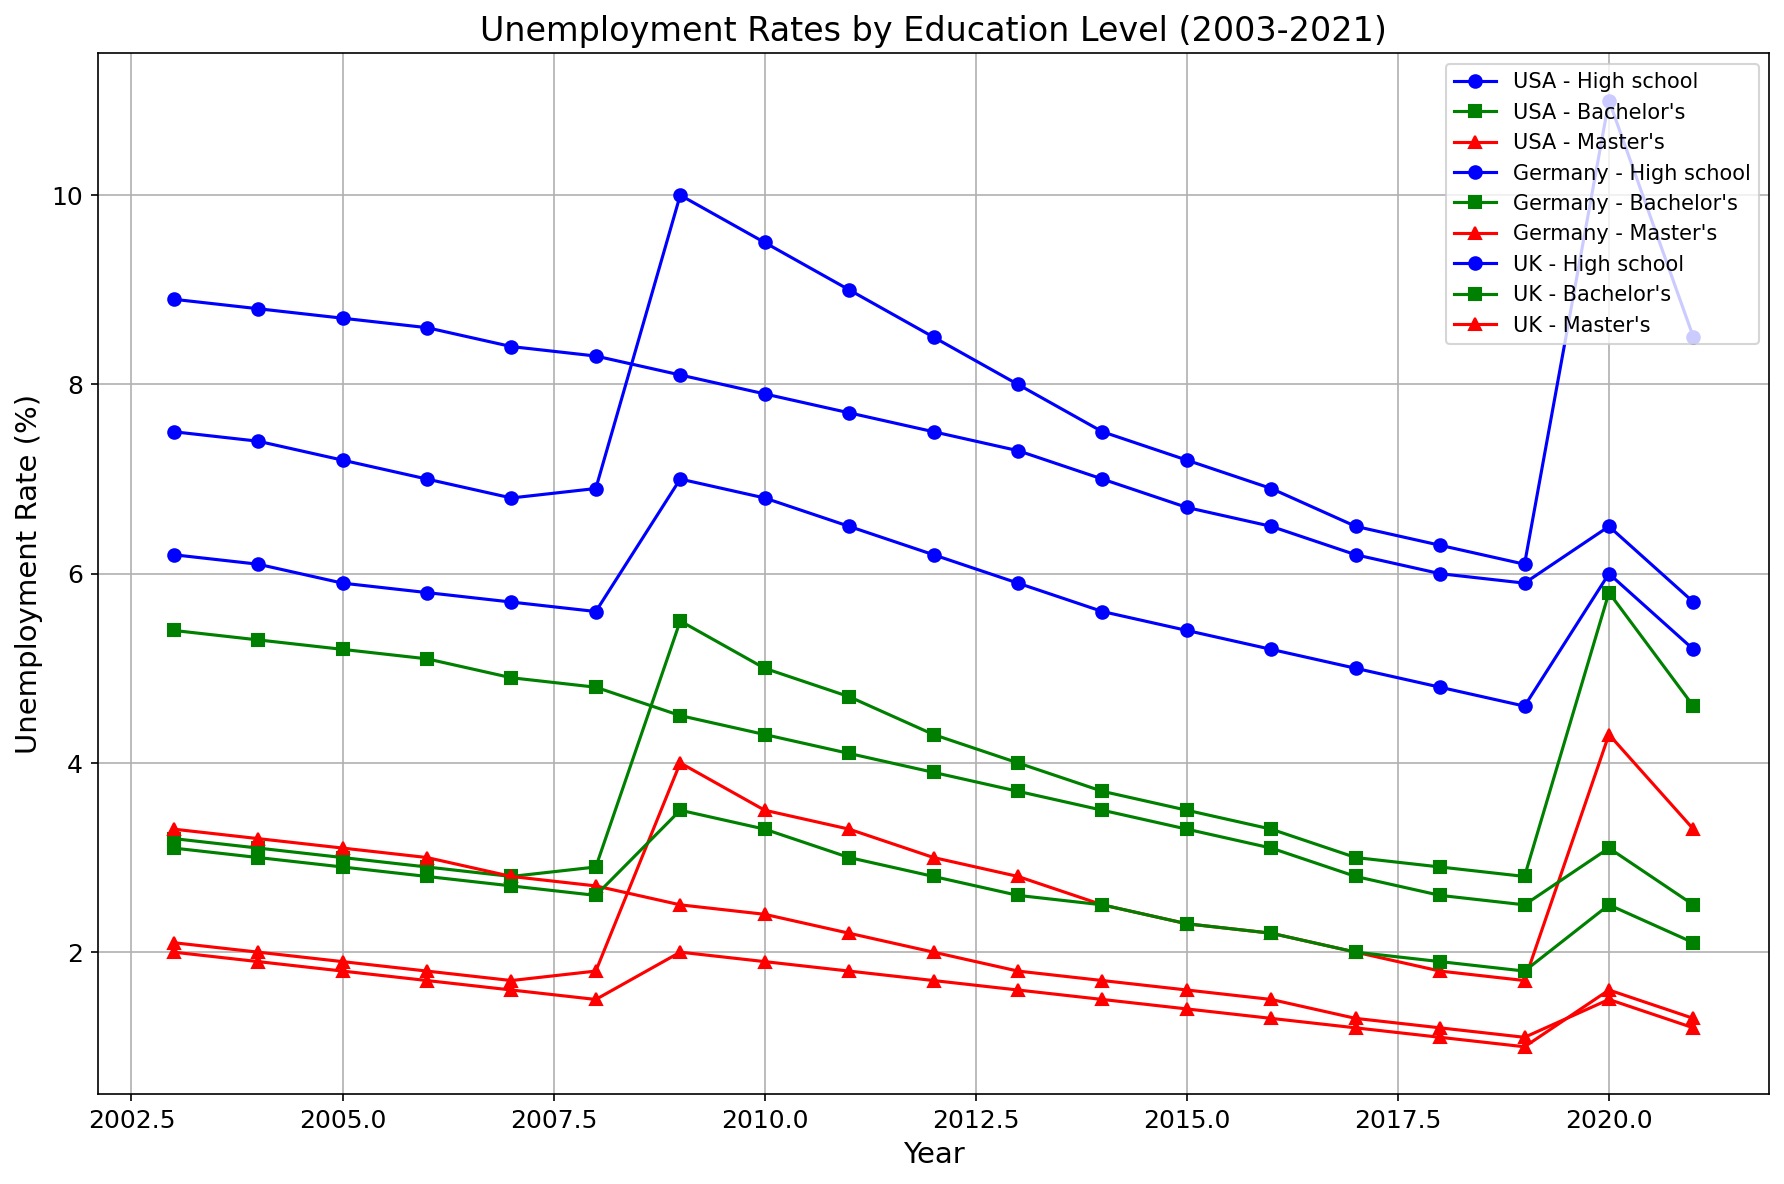What are the unemployment rates for Germany with a Bachelor's degree in 2012 and 2021? Are they increasing or decreasing? Check the unemployment rate for Germany with a Bachelor's degree in 2012 and then in 2021. The data shows 3.9% in 2012 and 2.5% in 2021, indicating a decrease.
Answer: Decreasing Which country had the lowest recorded unemployment rate for those with a Master's degree and in which year? Look at the lines for Master's degree across all countries and observe the one with the lowest point. The UK in the year 2019 has the lowest recorded unemployment rate at 1.0%.
Answer: The UK in 2019 In which year did the USA experience the highest unemployment rate for those with a High school level education, and what was the rate? Observe the USA's High school unemployment line, and identify the peak year. The highest rate is in 2020 at 11.0%.
Answer: 2020, 11.0% Compare the general trend of unemployment rates for Master’s degree holders across the three countries. Is it increasing, decreasing, or inconsistent? Examine the Master’s degree lines for all three countries over the years. All three countries show a generally decreasing trend.
Answer: Decreasing Which education level consistently shows the highest unemployment rate across all countries? Compare the different education-level lines across all countries. High school education consistently shows the highest unemployment rate.
Answer: High school What is the highest year-over-year increase in unemployment rate for the UK with a High school education, and between which years does it occur? Observe the UK High school education line and calculate the differences between each year's rates, identifying the largest increase. The highest increase is between 2008 (5.6%) and 2009 (7.0%), which is 1.4%.
Answer: 2008 to 2009, 1.4% What was the unemployment rate for Bachelor's degree holders in the USA during the 2008 financial crisis year, and how much did it increase compared to 2007? Check the USA Bachelor's line for 2008, noting the rate (2.9%), and 2007 (2.8%); the increase is 0.1%.
Answer: 2008, increased by 0.1% Considering the unemployment rates for Master's degree holders, which country experienced the most stability from 2003 to 2021? Examine the Master's degree lines, noting the consistency and fluctuation. Germany's line exhibits the least fluctuation, indicating stability.
Answer: Germany During the years 2009-2010, which country saw a decrease in unemployment rate for Bachelor’s degree holders, and by how much? Compare the Bachelor's degree lines for each country between 2009 and 2010. Germany shows a decrease from 2009 (4.5%) to 2010 (4.3%), a drop of 0.2%.
Answer: Germany, 0.2% What are the visual indicators used to differentiate between education levels in the chart, and why are they effective? The chart uses different colors and markers for each education level: blue circles for High school, green squares for Bachelor's degree, and red triangles for Master's degree. These visual differences make it easy to identify and compare trends between education levels.
Answer: Colors and markers; effective for easy distinction 